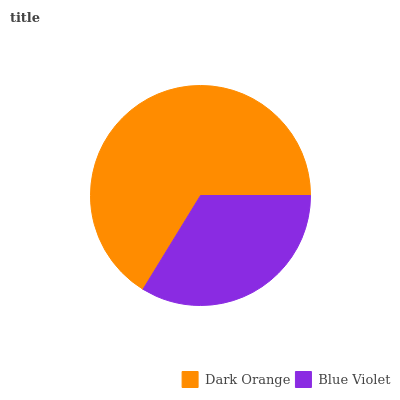Is Blue Violet the minimum?
Answer yes or no. Yes. Is Dark Orange the maximum?
Answer yes or no. Yes. Is Blue Violet the maximum?
Answer yes or no. No. Is Dark Orange greater than Blue Violet?
Answer yes or no. Yes. Is Blue Violet less than Dark Orange?
Answer yes or no. Yes. Is Blue Violet greater than Dark Orange?
Answer yes or no. No. Is Dark Orange less than Blue Violet?
Answer yes or no. No. Is Dark Orange the high median?
Answer yes or no. Yes. Is Blue Violet the low median?
Answer yes or no. Yes. Is Blue Violet the high median?
Answer yes or no. No. Is Dark Orange the low median?
Answer yes or no. No. 